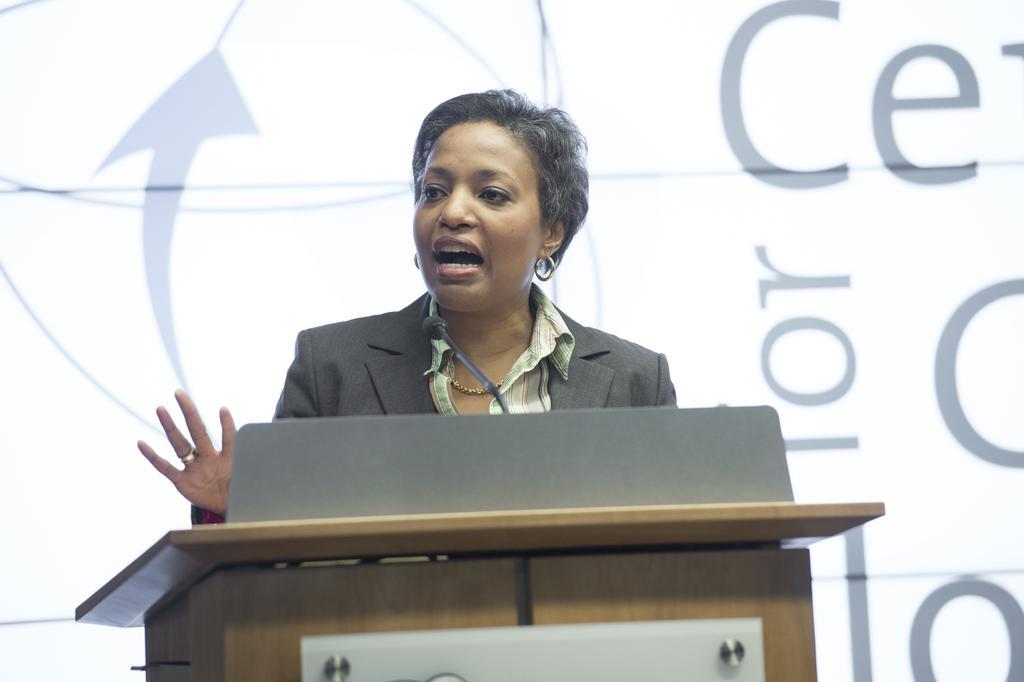Can you describe this image briefly? In this image there is a woman standing in front of the podium. On the podium there is a mic. In the background there is a banner. 